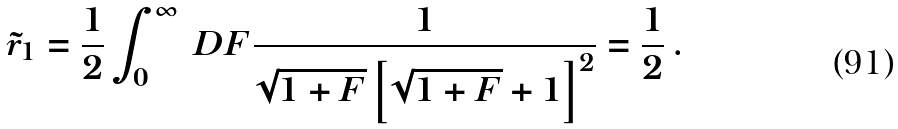Convert formula to latex. <formula><loc_0><loc_0><loc_500><loc_500>\tilde { r } _ { 1 } = \frac { 1 } { 2 } \int _ { 0 } ^ { \infty } \ D F \frac { 1 } { \sqrt { 1 + F } \left [ \sqrt { 1 + F } + 1 \right ] ^ { 2 } } = \frac { 1 } { 2 } \, .</formula> 